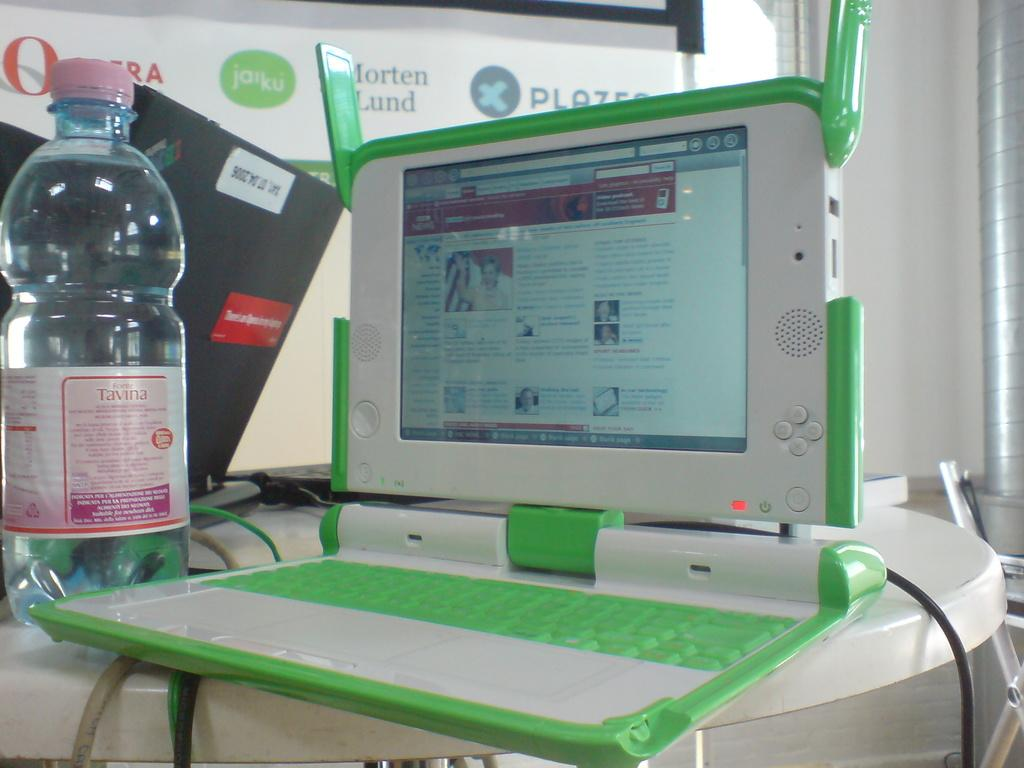<image>
Write a terse but informative summary of the picture. White and green laptop on a table next to a bottle of TAVINA. 